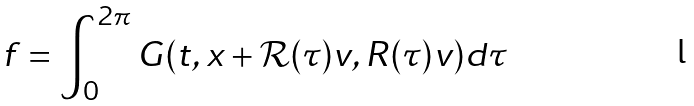Convert formula to latex. <formula><loc_0><loc_0><loc_500><loc_500>f = \int _ { 0 } ^ { 2 \pi } G ( t , x + \mathcal { R } ( \tau ) v , R ( \tau ) v ) d \tau</formula> 